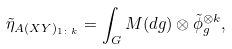<formula> <loc_0><loc_0><loc_500><loc_500>\tilde { \eta } _ { A ( X Y ) _ { 1 \colon k } } = \int _ { G } M ( d g ) \otimes \tilde { \phi } _ { g } ^ { \otimes k } ,</formula> 